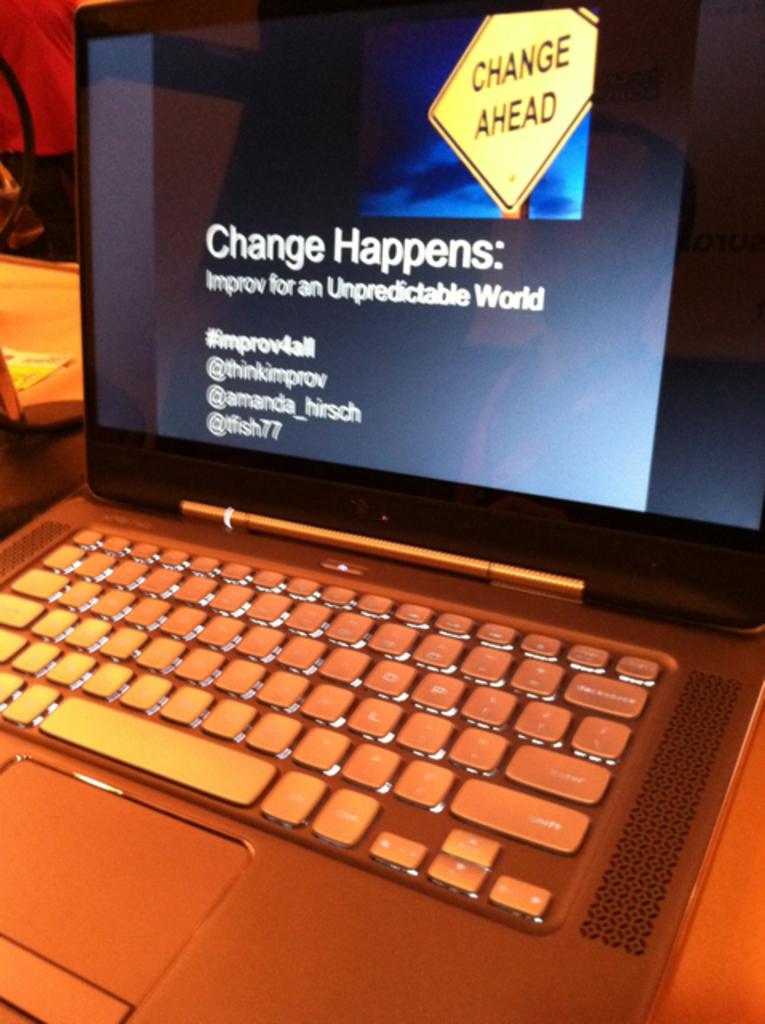What does change happen represent in the image?
Offer a very short reply. Improv for an unpredictable world. 